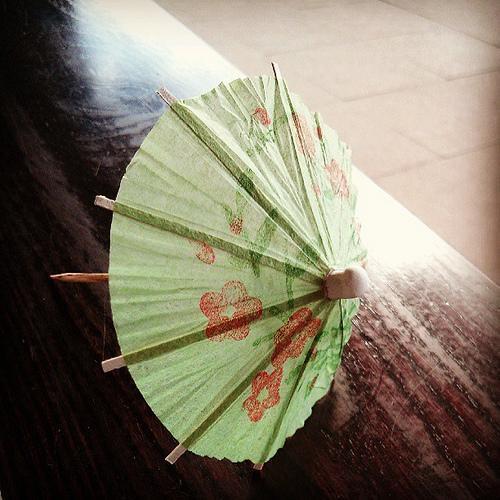How many umbrellas are on the table?
Give a very brief answer. 1. How many elephants are pictured?
Give a very brief answer. 0. How many dinosaurs are in the picture?
Give a very brief answer. 0. How many fans are pictured?
Give a very brief answer. 1. 